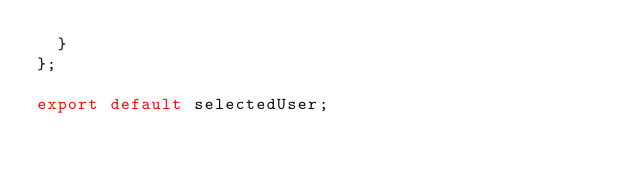Convert code to text. <code><loc_0><loc_0><loc_500><loc_500><_JavaScript_>  }
};

export default selectedUser;
</code> 